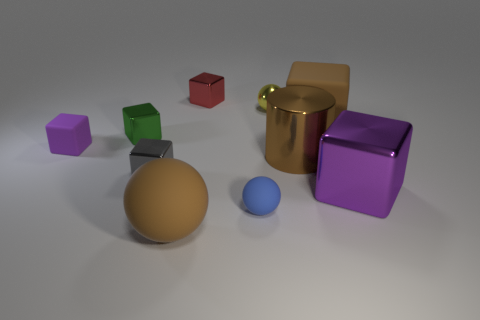There is a large rubber object that is behind the purple block that is left of the brown matte thing that is in front of the big purple metal object; what is its shape?
Offer a terse response. Cube. Do the gray block and the purple block that is on the left side of the small green metallic cube have the same size?
Keep it short and to the point. Yes. Are there any brown rubber balls of the same size as the brown rubber block?
Provide a short and direct response. Yes. How many other things are made of the same material as the tiny red thing?
Ensure brevity in your answer.  5. What is the color of the metallic block that is both in front of the small metallic ball and behind the shiny cylinder?
Keep it short and to the point. Green. Is the large brown object left of the tiny shiny ball made of the same material as the tiny red cube that is on the right side of the gray cube?
Your answer should be very brief. No. There is a sphere that is behind the blue rubber object; is it the same size as the brown shiny object?
Provide a succinct answer. No. There is a tiny shiny sphere; is it the same color as the large cube in front of the large brown matte cube?
Offer a very short reply. No. The rubber object that is the same color as the large sphere is what shape?
Provide a short and direct response. Cube. What is the shape of the yellow metal thing?
Make the answer very short. Sphere. 